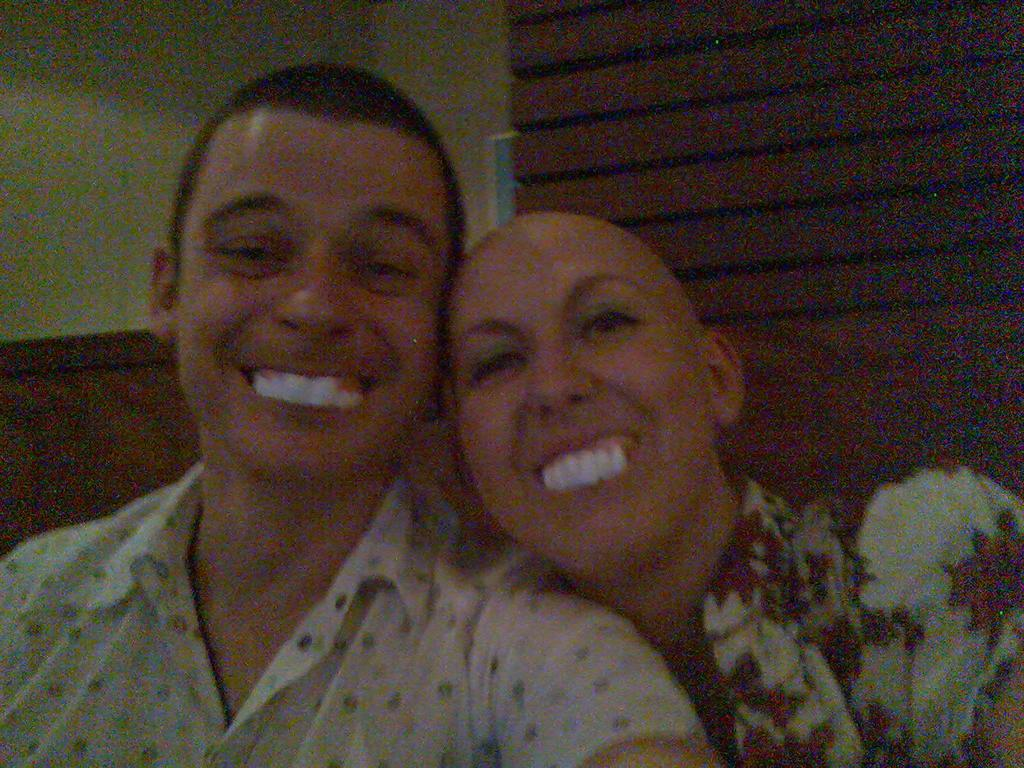Who are the people in the image? There is a man and a lady in the image. What are the expressions on their faces? Both the man and the lady are smiling in the image. What can be seen in the background of the image? There is a wall in the background of the image. What is the lady wearing? The lady is wearing a floral print shirt. What is the man wearing? The man is wearing a white shirt. Can you see any bees flying around the man and the lady in the image? There are no bees visible in the image. What type of feather is the lady holding in the image? There is no feather present in the image. 